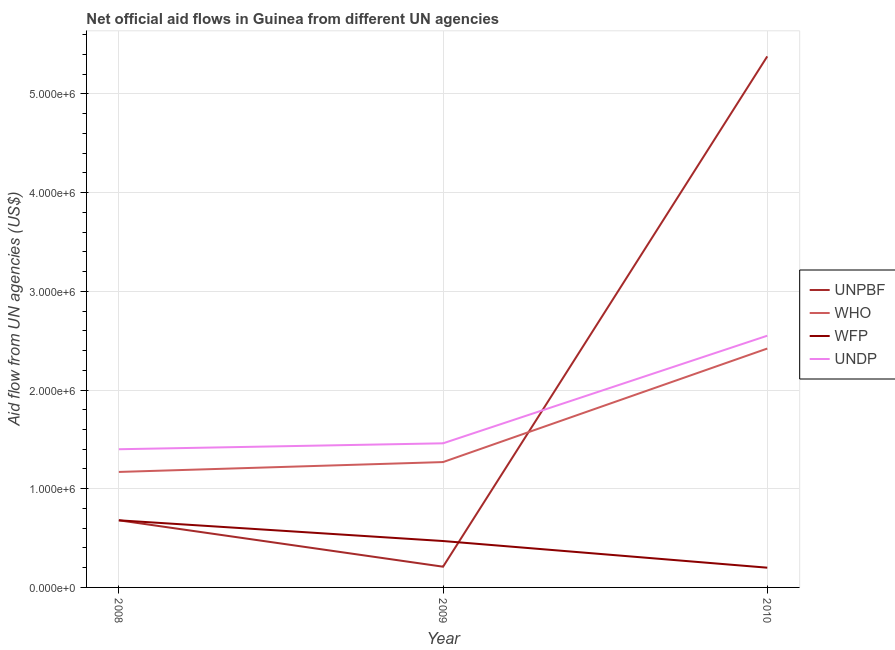How many different coloured lines are there?
Give a very brief answer. 4. Does the line corresponding to amount of aid given by undp intersect with the line corresponding to amount of aid given by wfp?
Provide a succinct answer. No. Is the number of lines equal to the number of legend labels?
Offer a very short reply. Yes. What is the amount of aid given by unpbf in 2010?
Your answer should be very brief. 5.38e+06. Across all years, what is the maximum amount of aid given by undp?
Give a very brief answer. 2.55e+06. Across all years, what is the minimum amount of aid given by unpbf?
Give a very brief answer. 2.10e+05. In which year was the amount of aid given by who maximum?
Offer a very short reply. 2010. In which year was the amount of aid given by who minimum?
Offer a very short reply. 2008. What is the total amount of aid given by wfp in the graph?
Give a very brief answer. 1.35e+06. What is the difference between the amount of aid given by unpbf in 2008 and that in 2010?
Ensure brevity in your answer.  -4.70e+06. What is the difference between the amount of aid given by who in 2009 and the amount of aid given by unpbf in 2010?
Provide a succinct answer. -4.11e+06. What is the average amount of aid given by wfp per year?
Offer a very short reply. 4.50e+05. In how many years, is the amount of aid given by unpbf greater than 2000000 US$?
Ensure brevity in your answer.  1. What is the ratio of the amount of aid given by who in 2008 to that in 2009?
Keep it short and to the point. 0.92. Is the amount of aid given by unpbf in 2008 less than that in 2010?
Provide a succinct answer. Yes. What is the difference between the highest and the second highest amount of aid given by unpbf?
Provide a succinct answer. 4.70e+06. What is the difference between the highest and the lowest amount of aid given by undp?
Your response must be concise. 1.15e+06. Is the sum of the amount of aid given by undp in 2009 and 2010 greater than the maximum amount of aid given by wfp across all years?
Offer a very short reply. Yes. Is the amount of aid given by unpbf strictly greater than the amount of aid given by wfp over the years?
Your response must be concise. No. Is the amount of aid given by unpbf strictly less than the amount of aid given by who over the years?
Provide a succinct answer. No. How many lines are there?
Give a very brief answer. 4. Are the values on the major ticks of Y-axis written in scientific E-notation?
Offer a terse response. Yes. Does the graph contain grids?
Provide a short and direct response. Yes. How are the legend labels stacked?
Offer a terse response. Vertical. What is the title of the graph?
Provide a short and direct response. Net official aid flows in Guinea from different UN agencies. Does "Secondary vocational education" appear as one of the legend labels in the graph?
Your answer should be very brief. No. What is the label or title of the Y-axis?
Your answer should be compact. Aid flow from UN agencies (US$). What is the Aid flow from UN agencies (US$) of UNPBF in 2008?
Provide a succinct answer. 6.80e+05. What is the Aid flow from UN agencies (US$) in WHO in 2008?
Offer a very short reply. 1.17e+06. What is the Aid flow from UN agencies (US$) of WFP in 2008?
Give a very brief answer. 6.80e+05. What is the Aid flow from UN agencies (US$) in UNDP in 2008?
Your answer should be very brief. 1.40e+06. What is the Aid flow from UN agencies (US$) of WHO in 2009?
Offer a terse response. 1.27e+06. What is the Aid flow from UN agencies (US$) of UNDP in 2009?
Offer a very short reply. 1.46e+06. What is the Aid flow from UN agencies (US$) of UNPBF in 2010?
Give a very brief answer. 5.38e+06. What is the Aid flow from UN agencies (US$) of WHO in 2010?
Your answer should be very brief. 2.42e+06. What is the Aid flow from UN agencies (US$) in UNDP in 2010?
Provide a short and direct response. 2.55e+06. Across all years, what is the maximum Aid flow from UN agencies (US$) in UNPBF?
Offer a very short reply. 5.38e+06. Across all years, what is the maximum Aid flow from UN agencies (US$) in WHO?
Your answer should be compact. 2.42e+06. Across all years, what is the maximum Aid flow from UN agencies (US$) of WFP?
Provide a short and direct response. 6.80e+05. Across all years, what is the maximum Aid flow from UN agencies (US$) in UNDP?
Offer a very short reply. 2.55e+06. Across all years, what is the minimum Aid flow from UN agencies (US$) in UNPBF?
Your answer should be very brief. 2.10e+05. Across all years, what is the minimum Aid flow from UN agencies (US$) in WHO?
Keep it short and to the point. 1.17e+06. Across all years, what is the minimum Aid flow from UN agencies (US$) in WFP?
Offer a very short reply. 2.00e+05. Across all years, what is the minimum Aid flow from UN agencies (US$) in UNDP?
Provide a succinct answer. 1.40e+06. What is the total Aid flow from UN agencies (US$) in UNPBF in the graph?
Ensure brevity in your answer.  6.27e+06. What is the total Aid flow from UN agencies (US$) in WHO in the graph?
Your answer should be very brief. 4.86e+06. What is the total Aid flow from UN agencies (US$) in WFP in the graph?
Keep it short and to the point. 1.35e+06. What is the total Aid flow from UN agencies (US$) in UNDP in the graph?
Ensure brevity in your answer.  5.41e+06. What is the difference between the Aid flow from UN agencies (US$) of UNPBF in 2008 and that in 2009?
Give a very brief answer. 4.70e+05. What is the difference between the Aid flow from UN agencies (US$) of UNPBF in 2008 and that in 2010?
Offer a terse response. -4.70e+06. What is the difference between the Aid flow from UN agencies (US$) in WHO in 2008 and that in 2010?
Keep it short and to the point. -1.25e+06. What is the difference between the Aid flow from UN agencies (US$) of UNDP in 2008 and that in 2010?
Ensure brevity in your answer.  -1.15e+06. What is the difference between the Aid flow from UN agencies (US$) of UNPBF in 2009 and that in 2010?
Offer a very short reply. -5.17e+06. What is the difference between the Aid flow from UN agencies (US$) of WHO in 2009 and that in 2010?
Your response must be concise. -1.15e+06. What is the difference between the Aid flow from UN agencies (US$) in UNDP in 2009 and that in 2010?
Keep it short and to the point. -1.09e+06. What is the difference between the Aid flow from UN agencies (US$) of UNPBF in 2008 and the Aid flow from UN agencies (US$) of WHO in 2009?
Make the answer very short. -5.90e+05. What is the difference between the Aid flow from UN agencies (US$) of UNPBF in 2008 and the Aid flow from UN agencies (US$) of UNDP in 2009?
Your answer should be very brief. -7.80e+05. What is the difference between the Aid flow from UN agencies (US$) in WHO in 2008 and the Aid flow from UN agencies (US$) in WFP in 2009?
Offer a terse response. 7.00e+05. What is the difference between the Aid flow from UN agencies (US$) of WHO in 2008 and the Aid flow from UN agencies (US$) of UNDP in 2009?
Offer a very short reply. -2.90e+05. What is the difference between the Aid flow from UN agencies (US$) of WFP in 2008 and the Aid flow from UN agencies (US$) of UNDP in 2009?
Provide a short and direct response. -7.80e+05. What is the difference between the Aid flow from UN agencies (US$) in UNPBF in 2008 and the Aid flow from UN agencies (US$) in WHO in 2010?
Offer a very short reply. -1.74e+06. What is the difference between the Aid flow from UN agencies (US$) of UNPBF in 2008 and the Aid flow from UN agencies (US$) of WFP in 2010?
Ensure brevity in your answer.  4.80e+05. What is the difference between the Aid flow from UN agencies (US$) of UNPBF in 2008 and the Aid flow from UN agencies (US$) of UNDP in 2010?
Offer a terse response. -1.87e+06. What is the difference between the Aid flow from UN agencies (US$) in WHO in 2008 and the Aid flow from UN agencies (US$) in WFP in 2010?
Offer a terse response. 9.70e+05. What is the difference between the Aid flow from UN agencies (US$) in WHO in 2008 and the Aid flow from UN agencies (US$) in UNDP in 2010?
Ensure brevity in your answer.  -1.38e+06. What is the difference between the Aid flow from UN agencies (US$) of WFP in 2008 and the Aid flow from UN agencies (US$) of UNDP in 2010?
Your answer should be compact. -1.87e+06. What is the difference between the Aid flow from UN agencies (US$) in UNPBF in 2009 and the Aid flow from UN agencies (US$) in WHO in 2010?
Make the answer very short. -2.21e+06. What is the difference between the Aid flow from UN agencies (US$) in UNPBF in 2009 and the Aid flow from UN agencies (US$) in UNDP in 2010?
Your response must be concise. -2.34e+06. What is the difference between the Aid flow from UN agencies (US$) in WHO in 2009 and the Aid flow from UN agencies (US$) in WFP in 2010?
Your answer should be very brief. 1.07e+06. What is the difference between the Aid flow from UN agencies (US$) of WHO in 2009 and the Aid flow from UN agencies (US$) of UNDP in 2010?
Your answer should be compact. -1.28e+06. What is the difference between the Aid flow from UN agencies (US$) in WFP in 2009 and the Aid flow from UN agencies (US$) in UNDP in 2010?
Keep it short and to the point. -2.08e+06. What is the average Aid flow from UN agencies (US$) of UNPBF per year?
Keep it short and to the point. 2.09e+06. What is the average Aid flow from UN agencies (US$) in WHO per year?
Your answer should be very brief. 1.62e+06. What is the average Aid flow from UN agencies (US$) of UNDP per year?
Offer a terse response. 1.80e+06. In the year 2008, what is the difference between the Aid flow from UN agencies (US$) in UNPBF and Aid flow from UN agencies (US$) in WHO?
Make the answer very short. -4.90e+05. In the year 2008, what is the difference between the Aid flow from UN agencies (US$) in UNPBF and Aid flow from UN agencies (US$) in WFP?
Keep it short and to the point. 0. In the year 2008, what is the difference between the Aid flow from UN agencies (US$) of UNPBF and Aid flow from UN agencies (US$) of UNDP?
Provide a short and direct response. -7.20e+05. In the year 2008, what is the difference between the Aid flow from UN agencies (US$) in WHO and Aid flow from UN agencies (US$) in WFP?
Your response must be concise. 4.90e+05. In the year 2008, what is the difference between the Aid flow from UN agencies (US$) of WFP and Aid flow from UN agencies (US$) of UNDP?
Make the answer very short. -7.20e+05. In the year 2009, what is the difference between the Aid flow from UN agencies (US$) in UNPBF and Aid flow from UN agencies (US$) in WHO?
Your answer should be compact. -1.06e+06. In the year 2009, what is the difference between the Aid flow from UN agencies (US$) in UNPBF and Aid flow from UN agencies (US$) in WFP?
Offer a terse response. -2.60e+05. In the year 2009, what is the difference between the Aid flow from UN agencies (US$) of UNPBF and Aid flow from UN agencies (US$) of UNDP?
Provide a succinct answer. -1.25e+06. In the year 2009, what is the difference between the Aid flow from UN agencies (US$) of WFP and Aid flow from UN agencies (US$) of UNDP?
Keep it short and to the point. -9.90e+05. In the year 2010, what is the difference between the Aid flow from UN agencies (US$) in UNPBF and Aid flow from UN agencies (US$) in WHO?
Your answer should be very brief. 2.96e+06. In the year 2010, what is the difference between the Aid flow from UN agencies (US$) of UNPBF and Aid flow from UN agencies (US$) of WFP?
Provide a succinct answer. 5.18e+06. In the year 2010, what is the difference between the Aid flow from UN agencies (US$) of UNPBF and Aid flow from UN agencies (US$) of UNDP?
Offer a very short reply. 2.83e+06. In the year 2010, what is the difference between the Aid flow from UN agencies (US$) in WHO and Aid flow from UN agencies (US$) in WFP?
Offer a very short reply. 2.22e+06. In the year 2010, what is the difference between the Aid flow from UN agencies (US$) of WHO and Aid flow from UN agencies (US$) of UNDP?
Keep it short and to the point. -1.30e+05. In the year 2010, what is the difference between the Aid flow from UN agencies (US$) of WFP and Aid flow from UN agencies (US$) of UNDP?
Provide a succinct answer. -2.35e+06. What is the ratio of the Aid flow from UN agencies (US$) in UNPBF in 2008 to that in 2009?
Offer a terse response. 3.24. What is the ratio of the Aid flow from UN agencies (US$) of WHO in 2008 to that in 2009?
Ensure brevity in your answer.  0.92. What is the ratio of the Aid flow from UN agencies (US$) of WFP in 2008 to that in 2009?
Provide a short and direct response. 1.45. What is the ratio of the Aid flow from UN agencies (US$) in UNDP in 2008 to that in 2009?
Provide a succinct answer. 0.96. What is the ratio of the Aid flow from UN agencies (US$) in UNPBF in 2008 to that in 2010?
Your answer should be compact. 0.13. What is the ratio of the Aid flow from UN agencies (US$) of WHO in 2008 to that in 2010?
Provide a short and direct response. 0.48. What is the ratio of the Aid flow from UN agencies (US$) of WFP in 2008 to that in 2010?
Your response must be concise. 3.4. What is the ratio of the Aid flow from UN agencies (US$) in UNDP in 2008 to that in 2010?
Offer a very short reply. 0.55. What is the ratio of the Aid flow from UN agencies (US$) in UNPBF in 2009 to that in 2010?
Offer a very short reply. 0.04. What is the ratio of the Aid flow from UN agencies (US$) in WHO in 2009 to that in 2010?
Your response must be concise. 0.52. What is the ratio of the Aid flow from UN agencies (US$) of WFP in 2009 to that in 2010?
Your response must be concise. 2.35. What is the ratio of the Aid flow from UN agencies (US$) of UNDP in 2009 to that in 2010?
Provide a short and direct response. 0.57. What is the difference between the highest and the second highest Aid flow from UN agencies (US$) in UNPBF?
Keep it short and to the point. 4.70e+06. What is the difference between the highest and the second highest Aid flow from UN agencies (US$) in WHO?
Provide a succinct answer. 1.15e+06. What is the difference between the highest and the second highest Aid flow from UN agencies (US$) of WFP?
Offer a terse response. 2.10e+05. What is the difference between the highest and the second highest Aid flow from UN agencies (US$) in UNDP?
Ensure brevity in your answer.  1.09e+06. What is the difference between the highest and the lowest Aid flow from UN agencies (US$) of UNPBF?
Make the answer very short. 5.17e+06. What is the difference between the highest and the lowest Aid flow from UN agencies (US$) in WHO?
Keep it short and to the point. 1.25e+06. What is the difference between the highest and the lowest Aid flow from UN agencies (US$) in UNDP?
Make the answer very short. 1.15e+06. 